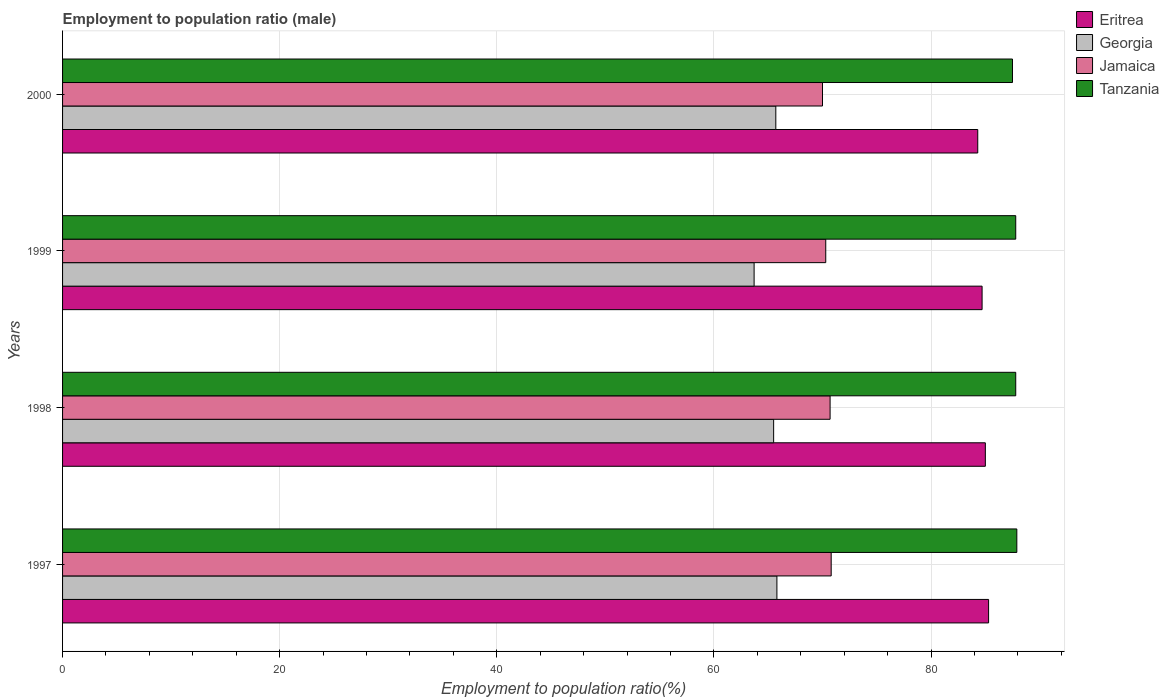How many different coloured bars are there?
Your response must be concise. 4. Are the number of bars on each tick of the Y-axis equal?
Give a very brief answer. Yes. How many bars are there on the 3rd tick from the top?
Your answer should be very brief. 4. How many bars are there on the 4th tick from the bottom?
Ensure brevity in your answer.  4. In how many cases, is the number of bars for a given year not equal to the number of legend labels?
Give a very brief answer. 0. What is the employment to population ratio in Georgia in 1999?
Offer a very short reply. 63.7. Across all years, what is the maximum employment to population ratio in Tanzania?
Provide a succinct answer. 87.9. Across all years, what is the minimum employment to population ratio in Eritrea?
Your answer should be very brief. 84.3. In which year was the employment to population ratio in Jamaica minimum?
Your answer should be very brief. 2000. What is the total employment to population ratio in Tanzania in the graph?
Keep it short and to the point. 351. What is the difference between the employment to population ratio in Georgia in 1998 and that in 2000?
Give a very brief answer. -0.2. What is the difference between the employment to population ratio in Eritrea in 1998 and the employment to population ratio in Tanzania in 1997?
Keep it short and to the point. -2.9. What is the average employment to population ratio in Jamaica per year?
Keep it short and to the point. 70.45. In the year 2000, what is the difference between the employment to population ratio in Tanzania and employment to population ratio in Eritrea?
Your response must be concise. 3.2. In how many years, is the employment to population ratio in Eritrea greater than 64 %?
Provide a short and direct response. 4. What is the ratio of the employment to population ratio in Eritrea in 1998 to that in 2000?
Offer a terse response. 1.01. Is the employment to population ratio in Eritrea in 1998 less than that in 2000?
Your answer should be very brief. No. What is the difference between the highest and the second highest employment to population ratio in Eritrea?
Ensure brevity in your answer.  0.3. What is the difference between the highest and the lowest employment to population ratio in Tanzania?
Give a very brief answer. 0.4. Is the sum of the employment to population ratio in Eritrea in 1997 and 2000 greater than the maximum employment to population ratio in Jamaica across all years?
Make the answer very short. Yes. Is it the case that in every year, the sum of the employment to population ratio in Georgia and employment to population ratio in Jamaica is greater than the sum of employment to population ratio in Tanzania and employment to population ratio in Eritrea?
Your response must be concise. No. What does the 3rd bar from the top in 2000 represents?
Your answer should be very brief. Georgia. What does the 2nd bar from the bottom in 1998 represents?
Offer a very short reply. Georgia. Are all the bars in the graph horizontal?
Provide a short and direct response. Yes. What is the difference between two consecutive major ticks on the X-axis?
Make the answer very short. 20. Does the graph contain grids?
Provide a succinct answer. Yes. What is the title of the graph?
Make the answer very short. Employment to population ratio (male). Does "Latin America(all income levels)" appear as one of the legend labels in the graph?
Keep it short and to the point. No. What is the Employment to population ratio(%) in Eritrea in 1997?
Ensure brevity in your answer.  85.3. What is the Employment to population ratio(%) of Georgia in 1997?
Keep it short and to the point. 65.8. What is the Employment to population ratio(%) in Jamaica in 1997?
Keep it short and to the point. 70.8. What is the Employment to population ratio(%) in Tanzania in 1997?
Offer a terse response. 87.9. What is the Employment to population ratio(%) in Georgia in 1998?
Keep it short and to the point. 65.5. What is the Employment to population ratio(%) in Jamaica in 1998?
Offer a terse response. 70.7. What is the Employment to population ratio(%) of Tanzania in 1998?
Keep it short and to the point. 87.8. What is the Employment to population ratio(%) in Eritrea in 1999?
Ensure brevity in your answer.  84.7. What is the Employment to population ratio(%) in Georgia in 1999?
Your answer should be compact. 63.7. What is the Employment to population ratio(%) in Jamaica in 1999?
Your response must be concise. 70.3. What is the Employment to population ratio(%) of Tanzania in 1999?
Provide a succinct answer. 87.8. What is the Employment to population ratio(%) in Eritrea in 2000?
Provide a short and direct response. 84.3. What is the Employment to population ratio(%) of Georgia in 2000?
Offer a terse response. 65.7. What is the Employment to population ratio(%) of Jamaica in 2000?
Ensure brevity in your answer.  70. What is the Employment to population ratio(%) of Tanzania in 2000?
Provide a succinct answer. 87.5. Across all years, what is the maximum Employment to population ratio(%) in Eritrea?
Offer a terse response. 85.3. Across all years, what is the maximum Employment to population ratio(%) in Georgia?
Your answer should be very brief. 65.8. Across all years, what is the maximum Employment to population ratio(%) of Jamaica?
Offer a terse response. 70.8. Across all years, what is the maximum Employment to population ratio(%) of Tanzania?
Make the answer very short. 87.9. Across all years, what is the minimum Employment to population ratio(%) of Eritrea?
Keep it short and to the point. 84.3. Across all years, what is the minimum Employment to population ratio(%) in Georgia?
Ensure brevity in your answer.  63.7. Across all years, what is the minimum Employment to population ratio(%) in Tanzania?
Make the answer very short. 87.5. What is the total Employment to population ratio(%) of Eritrea in the graph?
Offer a very short reply. 339.3. What is the total Employment to population ratio(%) of Georgia in the graph?
Keep it short and to the point. 260.7. What is the total Employment to population ratio(%) of Jamaica in the graph?
Offer a terse response. 281.8. What is the total Employment to population ratio(%) in Tanzania in the graph?
Provide a short and direct response. 351. What is the difference between the Employment to population ratio(%) in Eritrea in 1997 and that in 1998?
Ensure brevity in your answer.  0.3. What is the difference between the Employment to population ratio(%) in Georgia in 1997 and that in 1998?
Give a very brief answer. 0.3. What is the difference between the Employment to population ratio(%) in Jamaica in 1997 and that in 1998?
Offer a terse response. 0.1. What is the difference between the Employment to population ratio(%) of Tanzania in 1997 and that in 1998?
Your answer should be compact. 0.1. What is the difference between the Employment to population ratio(%) of Eritrea in 1997 and that in 1999?
Give a very brief answer. 0.6. What is the difference between the Employment to population ratio(%) in Tanzania in 1997 and that in 1999?
Make the answer very short. 0.1. What is the difference between the Employment to population ratio(%) of Jamaica in 1997 and that in 2000?
Your answer should be compact. 0.8. What is the difference between the Employment to population ratio(%) in Jamaica in 1998 and that in 1999?
Your response must be concise. 0.4. What is the difference between the Employment to population ratio(%) in Tanzania in 1998 and that in 1999?
Offer a very short reply. 0. What is the difference between the Employment to population ratio(%) in Georgia in 1998 and that in 2000?
Offer a terse response. -0.2. What is the difference between the Employment to population ratio(%) in Jamaica in 1998 and that in 2000?
Give a very brief answer. 0.7. What is the difference between the Employment to population ratio(%) of Tanzania in 1998 and that in 2000?
Give a very brief answer. 0.3. What is the difference between the Employment to population ratio(%) in Georgia in 1999 and that in 2000?
Give a very brief answer. -2. What is the difference between the Employment to population ratio(%) of Tanzania in 1999 and that in 2000?
Your answer should be compact. 0.3. What is the difference between the Employment to population ratio(%) in Eritrea in 1997 and the Employment to population ratio(%) in Georgia in 1998?
Ensure brevity in your answer.  19.8. What is the difference between the Employment to population ratio(%) in Eritrea in 1997 and the Employment to population ratio(%) in Tanzania in 1998?
Offer a very short reply. -2.5. What is the difference between the Employment to population ratio(%) of Georgia in 1997 and the Employment to population ratio(%) of Jamaica in 1998?
Keep it short and to the point. -4.9. What is the difference between the Employment to population ratio(%) of Jamaica in 1997 and the Employment to population ratio(%) of Tanzania in 1998?
Make the answer very short. -17. What is the difference between the Employment to population ratio(%) of Eritrea in 1997 and the Employment to population ratio(%) of Georgia in 1999?
Provide a short and direct response. 21.6. What is the difference between the Employment to population ratio(%) in Georgia in 1997 and the Employment to population ratio(%) in Jamaica in 1999?
Your response must be concise. -4.5. What is the difference between the Employment to population ratio(%) of Eritrea in 1997 and the Employment to population ratio(%) of Georgia in 2000?
Your answer should be very brief. 19.6. What is the difference between the Employment to population ratio(%) of Eritrea in 1997 and the Employment to population ratio(%) of Tanzania in 2000?
Your answer should be compact. -2.2. What is the difference between the Employment to population ratio(%) in Georgia in 1997 and the Employment to population ratio(%) in Tanzania in 2000?
Keep it short and to the point. -21.7. What is the difference between the Employment to population ratio(%) of Jamaica in 1997 and the Employment to population ratio(%) of Tanzania in 2000?
Make the answer very short. -16.7. What is the difference between the Employment to population ratio(%) in Eritrea in 1998 and the Employment to population ratio(%) in Georgia in 1999?
Give a very brief answer. 21.3. What is the difference between the Employment to population ratio(%) in Eritrea in 1998 and the Employment to population ratio(%) in Jamaica in 1999?
Ensure brevity in your answer.  14.7. What is the difference between the Employment to population ratio(%) in Eritrea in 1998 and the Employment to population ratio(%) in Tanzania in 1999?
Make the answer very short. -2.8. What is the difference between the Employment to population ratio(%) of Georgia in 1998 and the Employment to population ratio(%) of Jamaica in 1999?
Provide a short and direct response. -4.8. What is the difference between the Employment to population ratio(%) of Georgia in 1998 and the Employment to population ratio(%) of Tanzania in 1999?
Offer a terse response. -22.3. What is the difference between the Employment to population ratio(%) in Jamaica in 1998 and the Employment to population ratio(%) in Tanzania in 1999?
Ensure brevity in your answer.  -17.1. What is the difference between the Employment to population ratio(%) in Eritrea in 1998 and the Employment to population ratio(%) in Georgia in 2000?
Give a very brief answer. 19.3. What is the difference between the Employment to population ratio(%) in Eritrea in 1998 and the Employment to population ratio(%) in Tanzania in 2000?
Your response must be concise. -2.5. What is the difference between the Employment to population ratio(%) of Georgia in 1998 and the Employment to population ratio(%) of Jamaica in 2000?
Offer a terse response. -4.5. What is the difference between the Employment to population ratio(%) of Georgia in 1998 and the Employment to population ratio(%) of Tanzania in 2000?
Provide a short and direct response. -22. What is the difference between the Employment to population ratio(%) in Jamaica in 1998 and the Employment to population ratio(%) in Tanzania in 2000?
Provide a succinct answer. -16.8. What is the difference between the Employment to population ratio(%) of Eritrea in 1999 and the Employment to population ratio(%) of Georgia in 2000?
Keep it short and to the point. 19. What is the difference between the Employment to population ratio(%) of Georgia in 1999 and the Employment to population ratio(%) of Jamaica in 2000?
Provide a succinct answer. -6.3. What is the difference between the Employment to population ratio(%) in Georgia in 1999 and the Employment to population ratio(%) in Tanzania in 2000?
Your answer should be very brief. -23.8. What is the difference between the Employment to population ratio(%) in Jamaica in 1999 and the Employment to population ratio(%) in Tanzania in 2000?
Provide a succinct answer. -17.2. What is the average Employment to population ratio(%) in Eritrea per year?
Keep it short and to the point. 84.83. What is the average Employment to population ratio(%) of Georgia per year?
Provide a short and direct response. 65.17. What is the average Employment to population ratio(%) of Jamaica per year?
Make the answer very short. 70.45. What is the average Employment to population ratio(%) in Tanzania per year?
Offer a terse response. 87.75. In the year 1997, what is the difference between the Employment to population ratio(%) of Eritrea and Employment to population ratio(%) of Georgia?
Your answer should be compact. 19.5. In the year 1997, what is the difference between the Employment to population ratio(%) in Georgia and Employment to population ratio(%) in Jamaica?
Make the answer very short. -5. In the year 1997, what is the difference between the Employment to population ratio(%) in Georgia and Employment to population ratio(%) in Tanzania?
Ensure brevity in your answer.  -22.1. In the year 1997, what is the difference between the Employment to population ratio(%) of Jamaica and Employment to population ratio(%) of Tanzania?
Keep it short and to the point. -17.1. In the year 1998, what is the difference between the Employment to population ratio(%) of Eritrea and Employment to population ratio(%) of Jamaica?
Provide a succinct answer. 14.3. In the year 1998, what is the difference between the Employment to population ratio(%) of Eritrea and Employment to population ratio(%) of Tanzania?
Offer a terse response. -2.8. In the year 1998, what is the difference between the Employment to population ratio(%) in Georgia and Employment to population ratio(%) in Tanzania?
Provide a short and direct response. -22.3. In the year 1998, what is the difference between the Employment to population ratio(%) in Jamaica and Employment to population ratio(%) in Tanzania?
Offer a terse response. -17.1. In the year 1999, what is the difference between the Employment to population ratio(%) of Georgia and Employment to population ratio(%) of Tanzania?
Provide a short and direct response. -24.1. In the year 1999, what is the difference between the Employment to population ratio(%) of Jamaica and Employment to population ratio(%) of Tanzania?
Offer a very short reply. -17.5. In the year 2000, what is the difference between the Employment to population ratio(%) of Eritrea and Employment to population ratio(%) of Georgia?
Your response must be concise. 18.6. In the year 2000, what is the difference between the Employment to population ratio(%) in Eritrea and Employment to population ratio(%) in Jamaica?
Give a very brief answer. 14.3. In the year 2000, what is the difference between the Employment to population ratio(%) in Georgia and Employment to population ratio(%) in Jamaica?
Give a very brief answer. -4.3. In the year 2000, what is the difference between the Employment to population ratio(%) of Georgia and Employment to population ratio(%) of Tanzania?
Keep it short and to the point. -21.8. In the year 2000, what is the difference between the Employment to population ratio(%) of Jamaica and Employment to population ratio(%) of Tanzania?
Offer a very short reply. -17.5. What is the ratio of the Employment to population ratio(%) in Jamaica in 1997 to that in 1998?
Offer a very short reply. 1. What is the ratio of the Employment to population ratio(%) in Eritrea in 1997 to that in 1999?
Keep it short and to the point. 1.01. What is the ratio of the Employment to population ratio(%) in Georgia in 1997 to that in 1999?
Your answer should be compact. 1.03. What is the ratio of the Employment to population ratio(%) of Jamaica in 1997 to that in 1999?
Make the answer very short. 1.01. What is the ratio of the Employment to population ratio(%) in Tanzania in 1997 to that in 1999?
Offer a very short reply. 1. What is the ratio of the Employment to population ratio(%) in Eritrea in 1997 to that in 2000?
Offer a very short reply. 1.01. What is the ratio of the Employment to population ratio(%) in Jamaica in 1997 to that in 2000?
Keep it short and to the point. 1.01. What is the ratio of the Employment to population ratio(%) of Eritrea in 1998 to that in 1999?
Ensure brevity in your answer.  1. What is the ratio of the Employment to population ratio(%) of Georgia in 1998 to that in 1999?
Your answer should be very brief. 1.03. What is the ratio of the Employment to population ratio(%) of Eritrea in 1998 to that in 2000?
Provide a short and direct response. 1.01. What is the ratio of the Employment to population ratio(%) of Tanzania in 1998 to that in 2000?
Your response must be concise. 1. What is the ratio of the Employment to population ratio(%) in Eritrea in 1999 to that in 2000?
Keep it short and to the point. 1. What is the ratio of the Employment to population ratio(%) of Georgia in 1999 to that in 2000?
Provide a succinct answer. 0.97. What is the ratio of the Employment to population ratio(%) of Tanzania in 1999 to that in 2000?
Your answer should be compact. 1. What is the difference between the highest and the second highest Employment to population ratio(%) of Georgia?
Give a very brief answer. 0.1. What is the difference between the highest and the second highest Employment to population ratio(%) of Tanzania?
Your answer should be very brief. 0.1. What is the difference between the highest and the lowest Employment to population ratio(%) in Eritrea?
Your answer should be very brief. 1. What is the difference between the highest and the lowest Employment to population ratio(%) in Georgia?
Your answer should be compact. 2.1. What is the difference between the highest and the lowest Employment to population ratio(%) of Jamaica?
Provide a succinct answer. 0.8. What is the difference between the highest and the lowest Employment to population ratio(%) of Tanzania?
Provide a short and direct response. 0.4. 